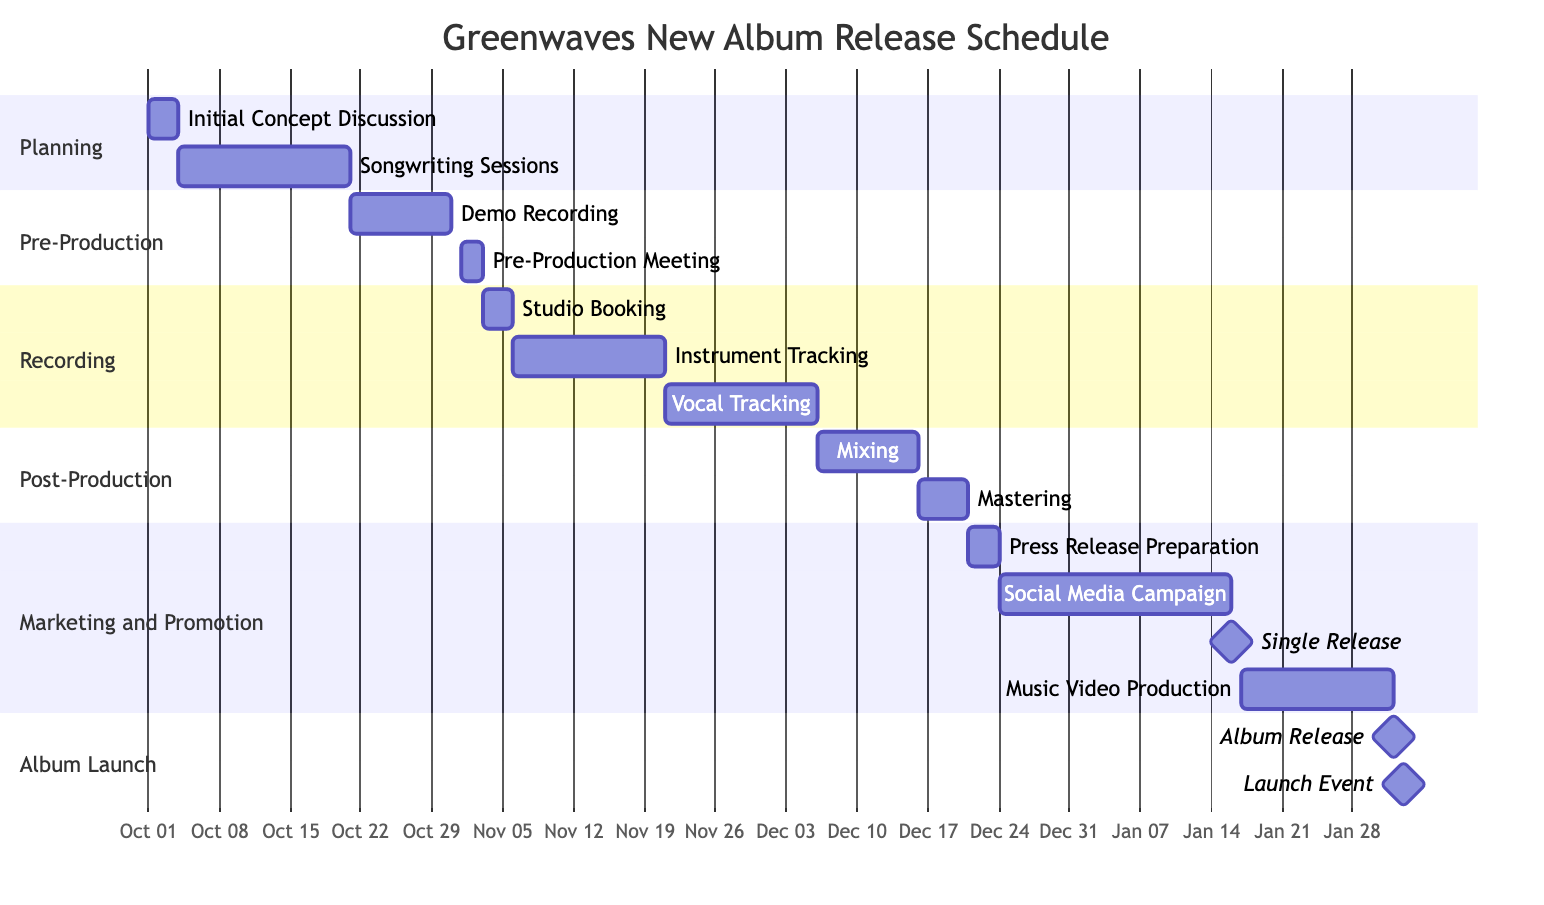What is the total number of phases in the release schedule? The diagram contains five distinct phases: Planning, Pre-Production, Recording, Post-Production, and Marketing and Promotion, which can be counted by looking at the section titles.
Answer: 5 What is the duration of the Vocal Tracking task? The Vocal Tracking task starts on November 21, 2023, and ends on December 5, 2023. By calculating the days between these dates, we find it lasts 15 days.
Answer: 15 days What is the timeframe for the Social Media Campaign? The Social Media Campaign starts on December 24, 2023, and ends on January 15, 2024. Counting the days in between gives a total duration of 23 days.
Answer: 23 days Which task directly follows the Mixing phase? After the Mixing phase on December 15, 2023, the next task that follows is Mastering, starting on December 16, 2023. The order of tasks can be determined by the timeline shown in the diagram.
Answer: Mastering What are the main tasks included in the Recording phase? The Recording phase includes the following tasks: Studio Booking, Instrument Tracking, and Vocal Tracking. They can be identified by looking at the section labeled Recording and listing the tasks within that section.
Answer: Studio Booking, Instrument Tracking, Vocal Tracking What milestone occurs on January 16, 2024? On January 16, 2024, the Single Release milestone is scheduled. This can be identified in the Marketing and Promotion section where it is marked as a milestone task.
Answer: Single Release How many days are allocated for the Album Release task? The Album Release task is a milestone event set for February 1, 2024, which means it doesn't have a duration but is a single point in time. Thus, it takes 0 days.
Answer: 0 days In which month does the Instrument Tracking task start? The Instrument Tracking task begins on November 6, 2023. By looking at the start date, we can see that it is in November.
Answer: November Which task has the longest duration in the Planning phase? In the Planning phase, the longest task is Songwriting Sessions, which takes 17 days from October 4 to October 20, 2023. This can be determined by examining the duration of each task in that phase.
Answer: Songwriting Sessions 